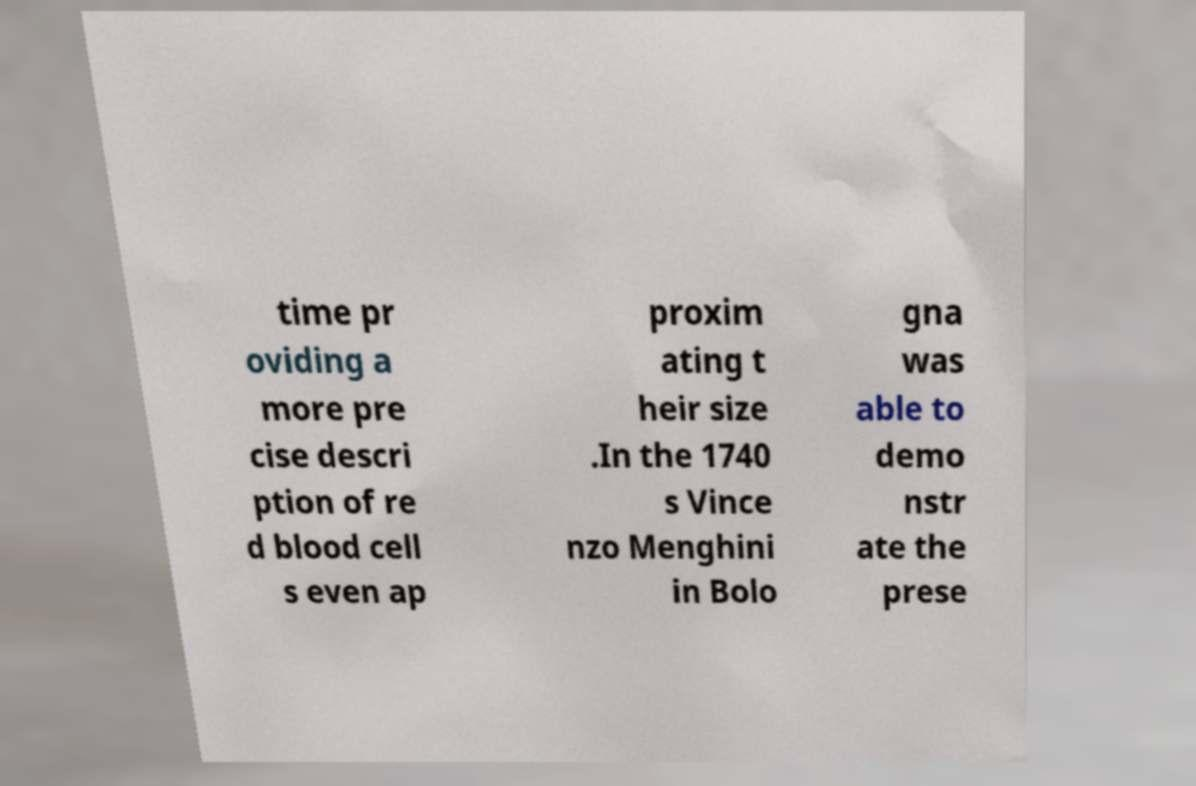Could you extract and type out the text from this image? time pr oviding a more pre cise descri ption of re d blood cell s even ap proxim ating t heir size .In the 1740 s Vince nzo Menghini in Bolo gna was able to demo nstr ate the prese 